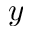Convert formula to latex. <formula><loc_0><loc_0><loc_500><loc_500>y</formula> 